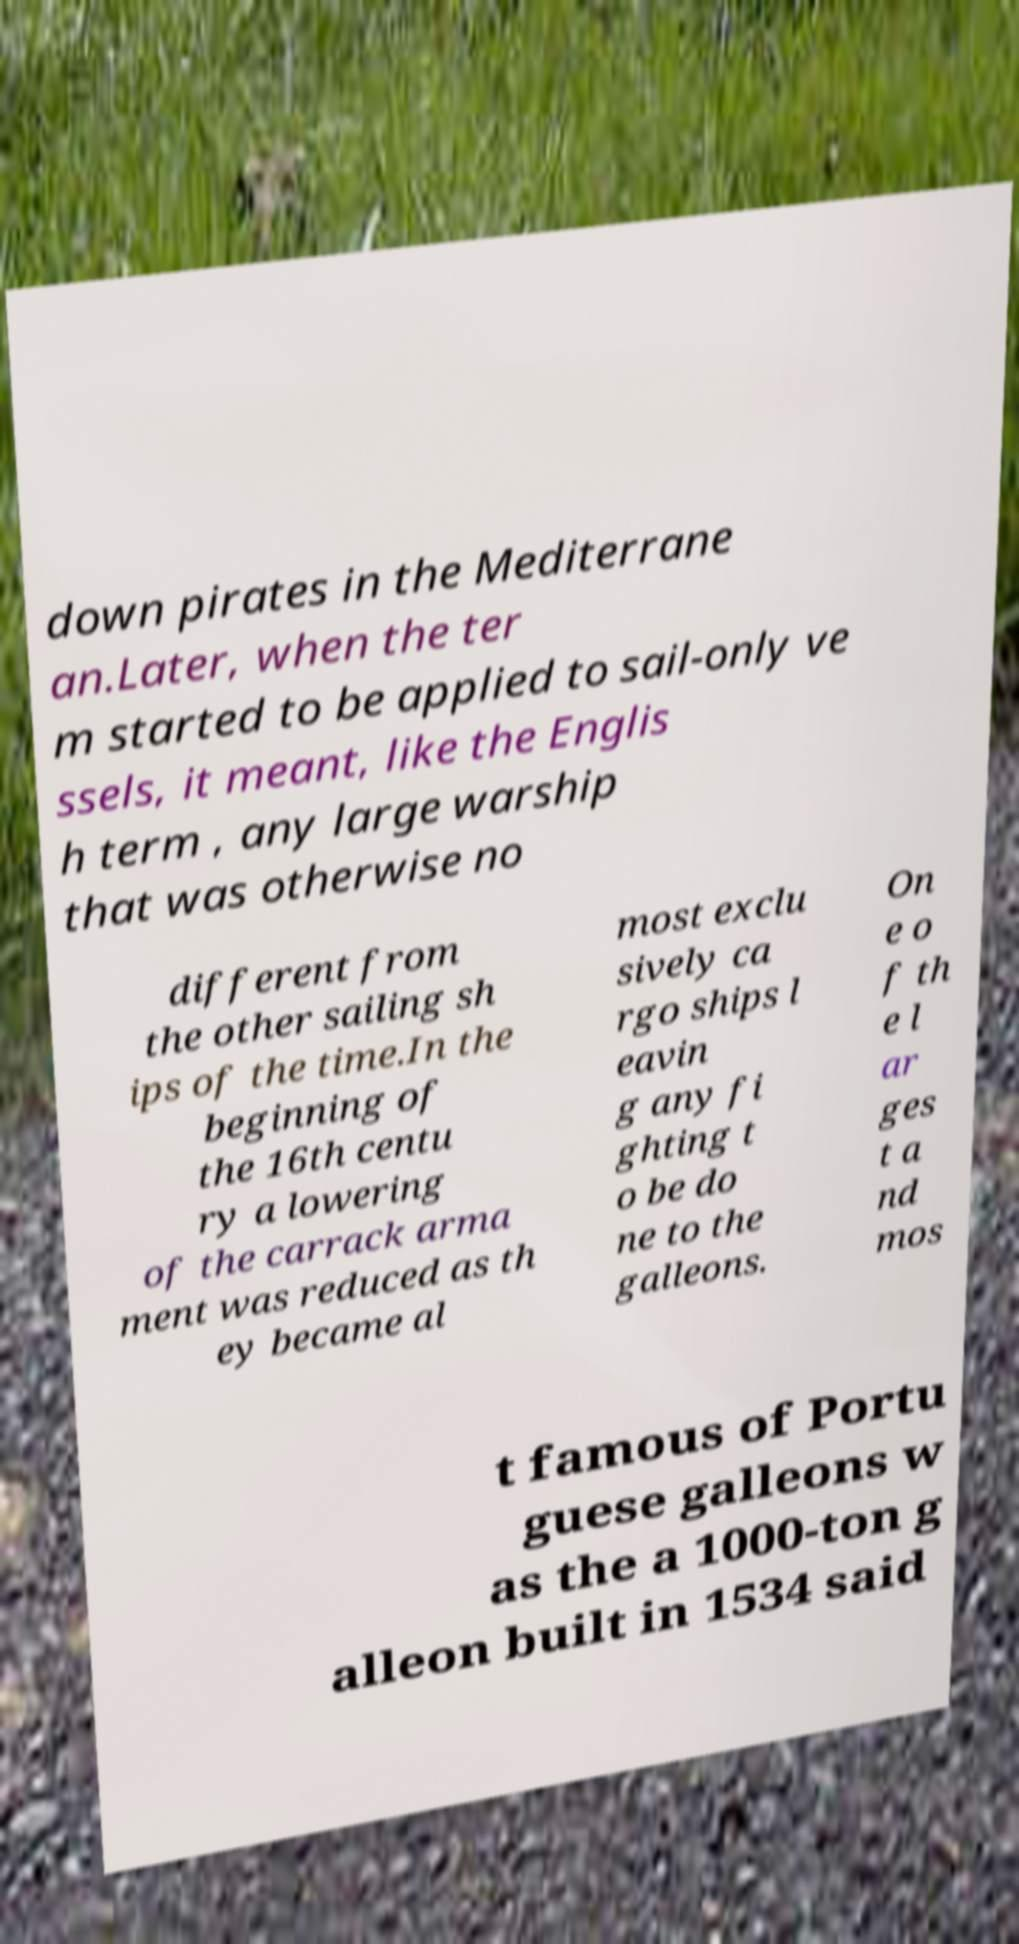There's text embedded in this image that I need extracted. Can you transcribe it verbatim? down pirates in the Mediterrane an.Later, when the ter m started to be applied to sail-only ve ssels, it meant, like the Englis h term , any large warship that was otherwise no different from the other sailing sh ips of the time.In the beginning of the 16th centu ry a lowering of the carrack arma ment was reduced as th ey became al most exclu sively ca rgo ships l eavin g any fi ghting t o be do ne to the galleons. On e o f th e l ar ges t a nd mos t famous of Portu guese galleons w as the a 1000-ton g alleon built in 1534 said 